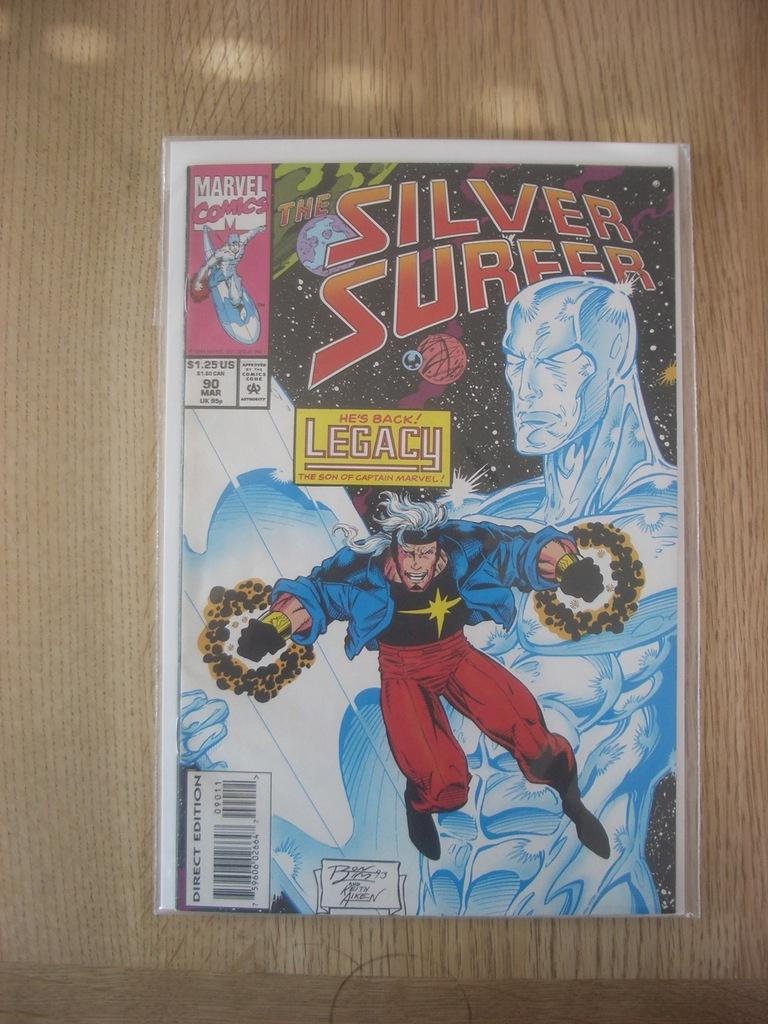<image>
Provide a brief description of the given image. A silver surfer comic in a plastic covering with, "He's back! Legacy," printed above a fling male. 